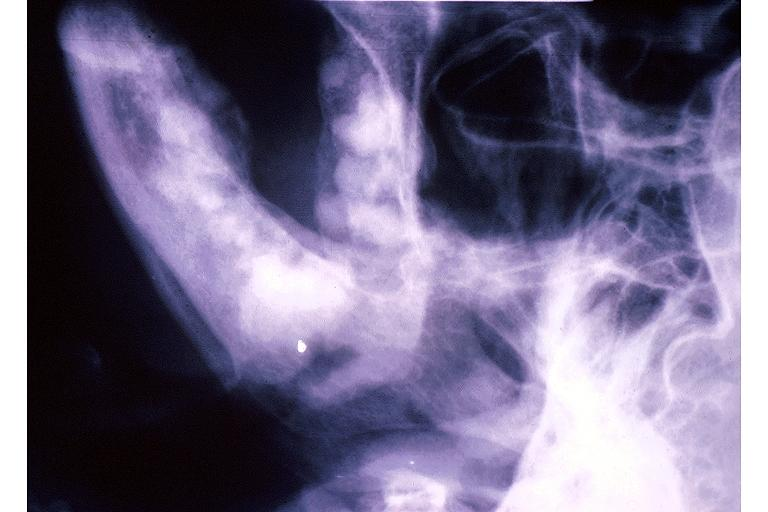does metastatic carcinoma breast show florid cemento-osseous dysplasia?
Answer the question using a single word or phrase. No 